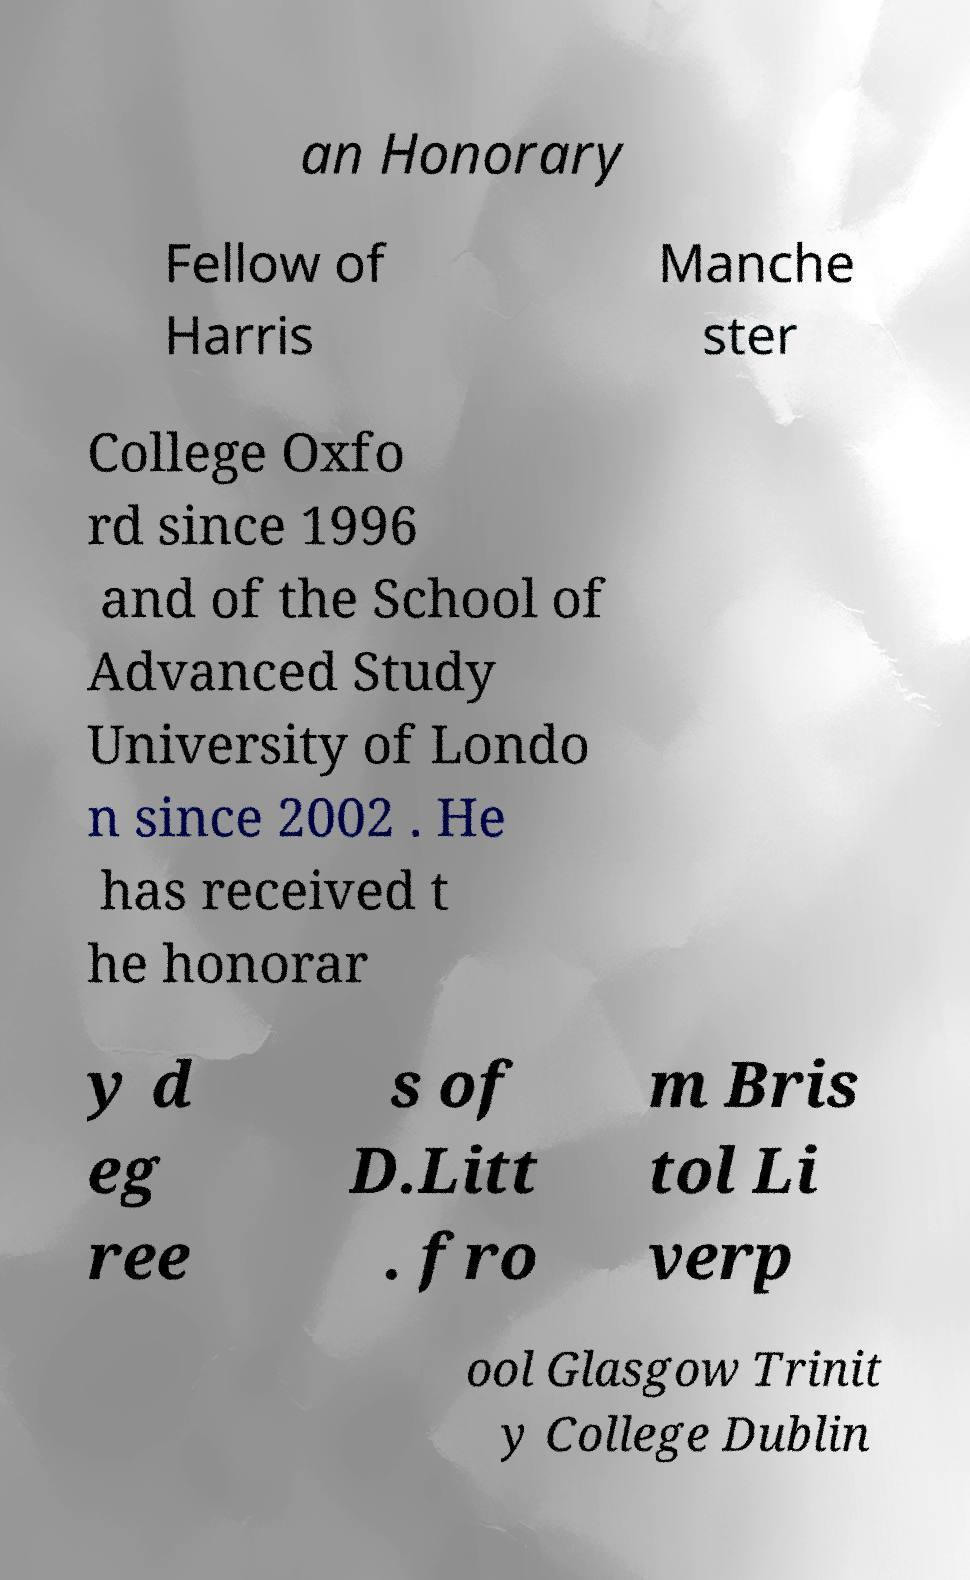Please identify and transcribe the text found in this image. an Honorary Fellow of Harris Manche ster College Oxfo rd since 1996 and of the School of Advanced Study University of Londo n since 2002 . He has received t he honorar y d eg ree s of D.Litt . fro m Bris tol Li verp ool Glasgow Trinit y College Dublin 